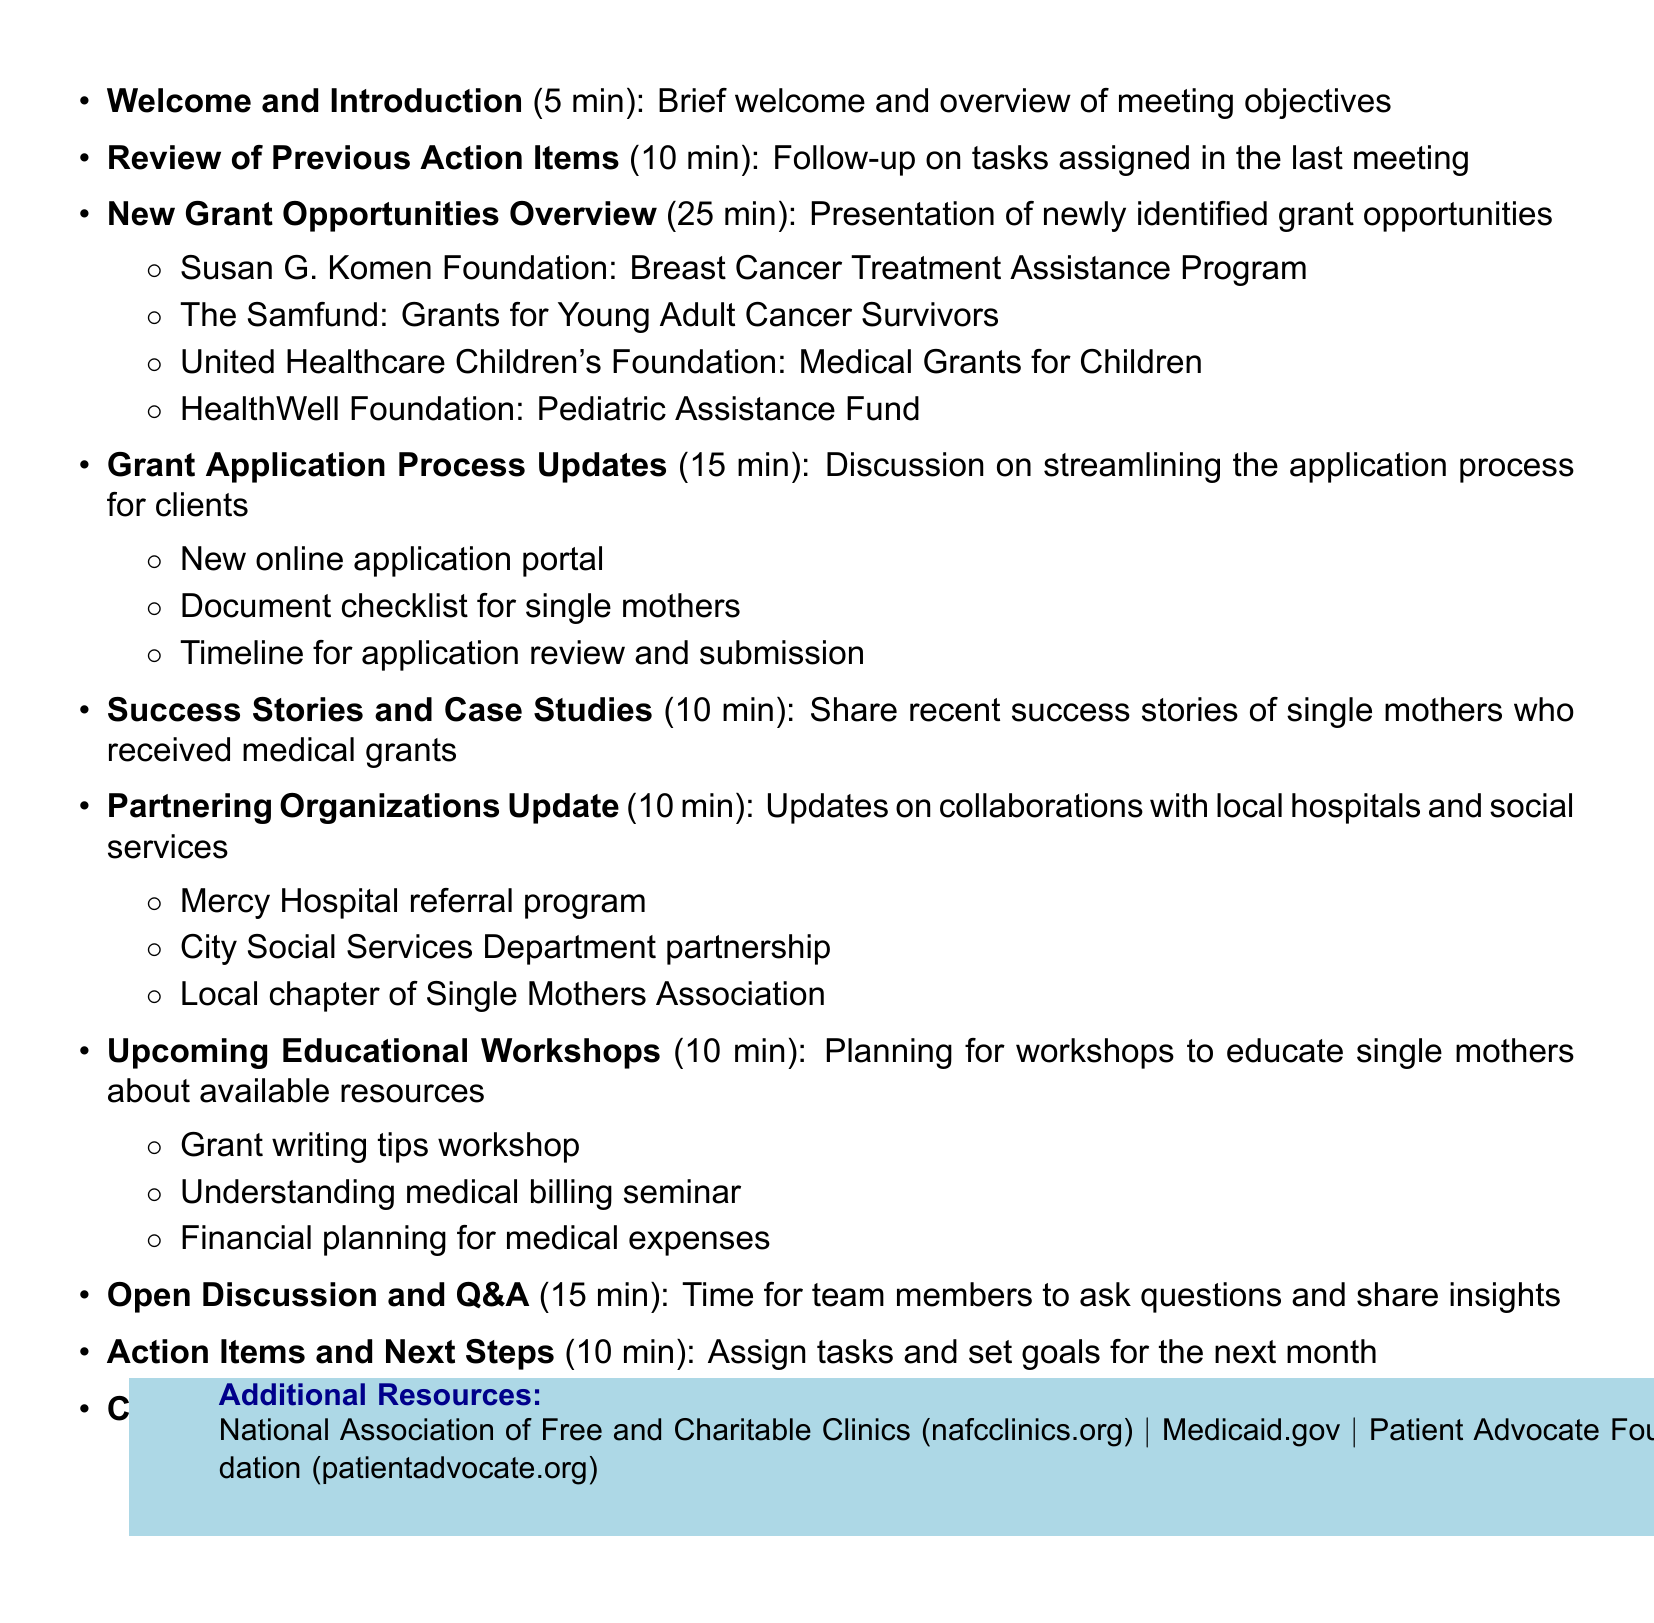What is the date of the meeting? The date of the meeting is specified in the meeting details section as June 15, 2023.
Answer: June 15, 2023 How long is the "New Grant Opportunities Overview" section? The duration for the "New Grant Opportunities Overview" is outlined in the agenda items, which is 25 minutes.
Answer: 25 minutes What is one organization mentioned in "New Grant Opportunities Overview"? One of the grant opportunities listed is from the Susan G. Komen Foundation, indicated in the sub-items of that agenda section.
Answer: Susan G. Komen Foundation What is the total duration of the meeting? The total duration is derived from the meeting start and end times, which is 1 hour and 30 minutes.
Answer: 1 hour and 30 minutes What is discussed during "Grant Application Process Updates"? This section discusses streamlining the application process, which is mentioned in the description of that agenda item.
Answer: Streamlining the application process How many sub-items are listed under "Upcoming Educational Workshops"? There are three specific workshops mentioned in the sub-items of that agenda item, which requires counting the listed workshops.
Answer: Three What is the purpose of the "Open Discussion and Q&A" section? The purpose is clearly stated in the agenda as being a time for team members to ask questions and share insights.
Answer: Ask questions and share insights What is the final agenda item titled? The last item in the agenda is explicitly labeled as "Closing Remarks."
Answer: Closing Remarks Which organization is affiliated with the directory of free clinics? The National Association of Free and Charitable Clinics is mentioned as providing a directory, accessible via their website.
Answer: National Association of Free and Charitable Clinics 